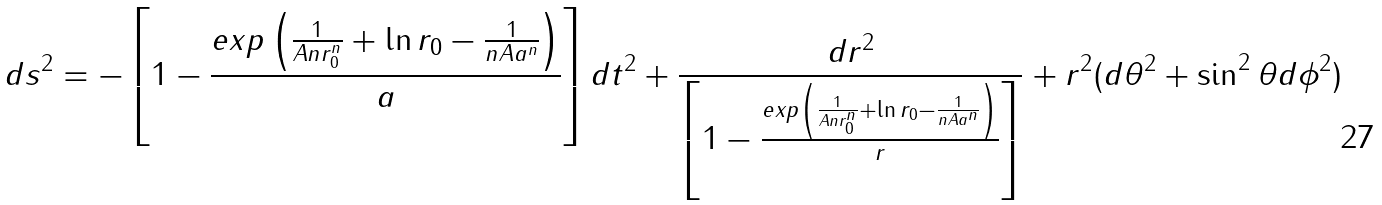Convert formula to latex. <formula><loc_0><loc_0><loc_500><loc_500>d s ^ { 2 } = - \left [ 1 - \frac { e x p \left ( \frac { 1 } { A n r _ { 0 } ^ { n } } + \ln r _ { 0 } - \frac { 1 } { n A a ^ { n } } \right ) } { a } \right ] d t ^ { 2 } + \frac { d r ^ { 2 } } { \left [ 1 - \frac { e x p \left ( \frac { 1 } { A n r _ { 0 } ^ { n } } + \ln r _ { 0 } - \frac { 1 } { n A a ^ { n } } \right ) } { r } \right ] } + r ^ { 2 } ( d \theta ^ { 2 } + \sin ^ { 2 } \theta d \phi ^ { 2 } )</formula> 